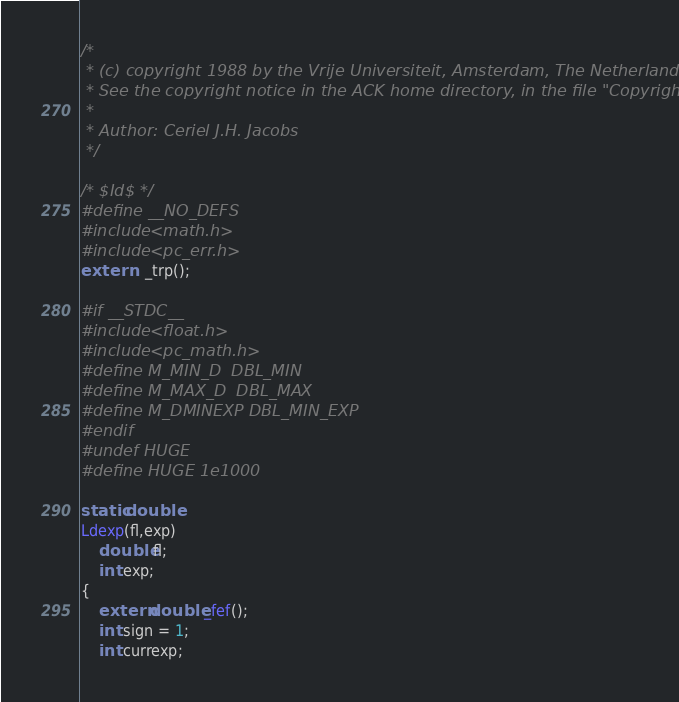Convert code to text. <code><loc_0><loc_0><loc_500><loc_500><_C_>/*
 * (c) copyright 1988 by the Vrije Universiteit, Amsterdam, The Netherlands.
 * See the copyright notice in the ACK home directory, in the file "Copyright".
 *
 * Author: Ceriel J.H. Jacobs
 */

/* $Id$ */
#define __NO_DEFS
#include <math.h>
#include <pc_err.h>
extern	_trp();

#if __STDC__
#include <float.h>
#include <pc_math.h>
#define M_MIN_D	DBL_MIN
#define M_MAX_D	DBL_MAX
#define M_DMINEXP DBL_MIN_EXP
#endif
#undef HUGE
#define HUGE	1e1000

static double
Ldexp(fl,exp)
	double fl;
	int exp;
{
	extern double _fef();
	int sign = 1;
	int currexp;
</code> 